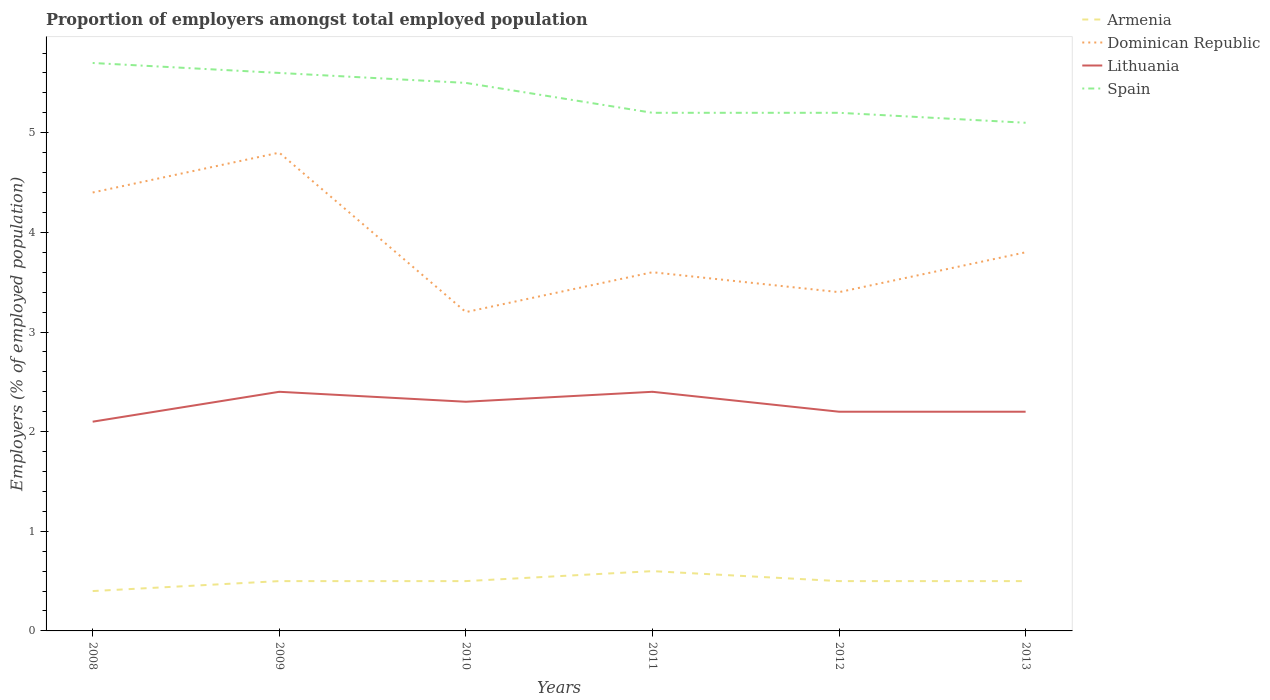How many different coloured lines are there?
Keep it short and to the point. 4. Is the number of lines equal to the number of legend labels?
Your answer should be very brief. Yes. Across all years, what is the maximum proportion of employers in Lithuania?
Your answer should be very brief. 2.1. In which year was the proportion of employers in Spain maximum?
Ensure brevity in your answer.  2013. What is the total proportion of employers in Dominican Republic in the graph?
Your response must be concise. 0.6. What is the difference between the highest and the second highest proportion of employers in Dominican Republic?
Your response must be concise. 1.6. Is the proportion of employers in Armenia strictly greater than the proportion of employers in Dominican Republic over the years?
Ensure brevity in your answer.  Yes. Are the values on the major ticks of Y-axis written in scientific E-notation?
Your answer should be very brief. No. Does the graph contain any zero values?
Offer a very short reply. No. Does the graph contain grids?
Provide a short and direct response. No. Where does the legend appear in the graph?
Provide a succinct answer. Top right. What is the title of the graph?
Give a very brief answer. Proportion of employers amongst total employed population. Does "Nicaragua" appear as one of the legend labels in the graph?
Offer a very short reply. No. What is the label or title of the Y-axis?
Offer a very short reply. Employers (% of employed population). What is the Employers (% of employed population) in Armenia in 2008?
Ensure brevity in your answer.  0.4. What is the Employers (% of employed population) in Dominican Republic in 2008?
Provide a short and direct response. 4.4. What is the Employers (% of employed population) in Lithuania in 2008?
Keep it short and to the point. 2.1. What is the Employers (% of employed population) in Spain in 2008?
Give a very brief answer. 5.7. What is the Employers (% of employed population) in Armenia in 2009?
Offer a terse response. 0.5. What is the Employers (% of employed population) of Dominican Republic in 2009?
Provide a short and direct response. 4.8. What is the Employers (% of employed population) in Lithuania in 2009?
Ensure brevity in your answer.  2.4. What is the Employers (% of employed population) in Spain in 2009?
Make the answer very short. 5.6. What is the Employers (% of employed population) in Armenia in 2010?
Keep it short and to the point. 0.5. What is the Employers (% of employed population) of Dominican Republic in 2010?
Keep it short and to the point. 3.2. What is the Employers (% of employed population) in Lithuania in 2010?
Provide a succinct answer. 2.3. What is the Employers (% of employed population) of Spain in 2010?
Your answer should be very brief. 5.5. What is the Employers (% of employed population) of Armenia in 2011?
Your answer should be very brief. 0.6. What is the Employers (% of employed population) in Dominican Republic in 2011?
Provide a short and direct response. 3.6. What is the Employers (% of employed population) of Lithuania in 2011?
Ensure brevity in your answer.  2.4. What is the Employers (% of employed population) of Spain in 2011?
Keep it short and to the point. 5.2. What is the Employers (% of employed population) of Armenia in 2012?
Your answer should be compact. 0.5. What is the Employers (% of employed population) of Dominican Republic in 2012?
Offer a terse response. 3.4. What is the Employers (% of employed population) in Lithuania in 2012?
Your response must be concise. 2.2. What is the Employers (% of employed population) of Spain in 2012?
Make the answer very short. 5.2. What is the Employers (% of employed population) in Dominican Republic in 2013?
Your response must be concise. 3.8. What is the Employers (% of employed population) of Lithuania in 2013?
Your answer should be compact. 2.2. What is the Employers (% of employed population) of Spain in 2013?
Your answer should be compact. 5.1. Across all years, what is the maximum Employers (% of employed population) of Armenia?
Your answer should be compact. 0.6. Across all years, what is the maximum Employers (% of employed population) in Dominican Republic?
Keep it short and to the point. 4.8. Across all years, what is the maximum Employers (% of employed population) of Lithuania?
Give a very brief answer. 2.4. Across all years, what is the maximum Employers (% of employed population) in Spain?
Give a very brief answer. 5.7. Across all years, what is the minimum Employers (% of employed population) of Armenia?
Offer a very short reply. 0.4. Across all years, what is the minimum Employers (% of employed population) in Dominican Republic?
Your response must be concise. 3.2. Across all years, what is the minimum Employers (% of employed population) in Lithuania?
Provide a succinct answer. 2.1. Across all years, what is the minimum Employers (% of employed population) of Spain?
Offer a terse response. 5.1. What is the total Employers (% of employed population) of Dominican Republic in the graph?
Your response must be concise. 23.2. What is the total Employers (% of employed population) of Lithuania in the graph?
Your answer should be compact. 13.6. What is the total Employers (% of employed population) in Spain in the graph?
Provide a short and direct response. 32.3. What is the difference between the Employers (% of employed population) of Armenia in 2008 and that in 2009?
Your answer should be very brief. -0.1. What is the difference between the Employers (% of employed population) in Dominican Republic in 2008 and that in 2009?
Keep it short and to the point. -0.4. What is the difference between the Employers (% of employed population) in Lithuania in 2008 and that in 2009?
Your response must be concise. -0.3. What is the difference between the Employers (% of employed population) in Spain in 2008 and that in 2009?
Your response must be concise. 0.1. What is the difference between the Employers (% of employed population) in Armenia in 2008 and that in 2010?
Give a very brief answer. -0.1. What is the difference between the Employers (% of employed population) of Armenia in 2008 and that in 2011?
Your answer should be compact. -0.2. What is the difference between the Employers (% of employed population) in Dominican Republic in 2008 and that in 2011?
Give a very brief answer. 0.8. What is the difference between the Employers (% of employed population) of Spain in 2008 and that in 2011?
Keep it short and to the point. 0.5. What is the difference between the Employers (% of employed population) in Dominican Republic in 2008 and that in 2012?
Your response must be concise. 1. What is the difference between the Employers (% of employed population) of Spain in 2008 and that in 2012?
Offer a terse response. 0.5. What is the difference between the Employers (% of employed population) of Lithuania in 2008 and that in 2013?
Make the answer very short. -0.1. What is the difference between the Employers (% of employed population) of Spain in 2008 and that in 2013?
Give a very brief answer. 0.6. What is the difference between the Employers (% of employed population) in Armenia in 2009 and that in 2010?
Your response must be concise. 0. What is the difference between the Employers (% of employed population) in Lithuania in 2009 and that in 2010?
Ensure brevity in your answer.  0.1. What is the difference between the Employers (% of employed population) in Spain in 2009 and that in 2010?
Give a very brief answer. 0.1. What is the difference between the Employers (% of employed population) in Lithuania in 2009 and that in 2011?
Give a very brief answer. 0. What is the difference between the Employers (% of employed population) of Armenia in 2009 and that in 2012?
Your answer should be very brief. 0. What is the difference between the Employers (% of employed population) of Dominican Republic in 2009 and that in 2012?
Provide a short and direct response. 1.4. What is the difference between the Employers (% of employed population) in Spain in 2009 and that in 2012?
Provide a succinct answer. 0.4. What is the difference between the Employers (% of employed population) in Lithuania in 2009 and that in 2013?
Provide a short and direct response. 0.2. What is the difference between the Employers (% of employed population) in Armenia in 2010 and that in 2011?
Provide a short and direct response. -0.1. What is the difference between the Employers (% of employed population) in Spain in 2010 and that in 2011?
Provide a succinct answer. 0.3. What is the difference between the Employers (% of employed population) in Dominican Republic in 2010 and that in 2012?
Offer a terse response. -0.2. What is the difference between the Employers (% of employed population) of Lithuania in 2010 and that in 2012?
Offer a very short reply. 0.1. What is the difference between the Employers (% of employed population) in Spain in 2010 and that in 2012?
Your response must be concise. 0.3. What is the difference between the Employers (% of employed population) in Armenia in 2010 and that in 2013?
Keep it short and to the point. 0. What is the difference between the Employers (% of employed population) of Dominican Republic in 2010 and that in 2013?
Provide a succinct answer. -0.6. What is the difference between the Employers (% of employed population) in Lithuania in 2010 and that in 2013?
Offer a terse response. 0.1. What is the difference between the Employers (% of employed population) in Spain in 2010 and that in 2013?
Your response must be concise. 0.4. What is the difference between the Employers (% of employed population) of Armenia in 2011 and that in 2012?
Keep it short and to the point. 0.1. What is the difference between the Employers (% of employed population) of Dominican Republic in 2011 and that in 2012?
Your answer should be very brief. 0.2. What is the difference between the Employers (% of employed population) of Lithuania in 2011 and that in 2012?
Ensure brevity in your answer.  0.2. What is the difference between the Employers (% of employed population) in Spain in 2011 and that in 2012?
Ensure brevity in your answer.  0. What is the difference between the Employers (% of employed population) in Spain in 2011 and that in 2013?
Offer a very short reply. 0.1. What is the difference between the Employers (% of employed population) of Armenia in 2012 and that in 2013?
Ensure brevity in your answer.  0. What is the difference between the Employers (% of employed population) of Dominican Republic in 2012 and that in 2013?
Your answer should be very brief. -0.4. What is the difference between the Employers (% of employed population) in Armenia in 2008 and the Employers (% of employed population) in Dominican Republic in 2009?
Give a very brief answer. -4.4. What is the difference between the Employers (% of employed population) of Armenia in 2008 and the Employers (% of employed population) of Lithuania in 2009?
Keep it short and to the point. -2. What is the difference between the Employers (% of employed population) of Dominican Republic in 2008 and the Employers (% of employed population) of Lithuania in 2009?
Ensure brevity in your answer.  2. What is the difference between the Employers (% of employed population) of Dominican Republic in 2008 and the Employers (% of employed population) of Spain in 2009?
Keep it short and to the point. -1.2. What is the difference between the Employers (% of employed population) of Armenia in 2008 and the Employers (% of employed population) of Dominican Republic in 2010?
Provide a succinct answer. -2.8. What is the difference between the Employers (% of employed population) in Armenia in 2008 and the Employers (% of employed population) in Lithuania in 2010?
Your answer should be compact. -1.9. What is the difference between the Employers (% of employed population) of Armenia in 2008 and the Employers (% of employed population) of Spain in 2010?
Give a very brief answer. -5.1. What is the difference between the Employers (% of employed population) in Dominican Republic in 2008 and the Employers (% of employed population) in Lithuania in 2010?
Give a very brief answer. 2.1. What is the difference between the Employers (% of employed population) of Armenia in 2008 and the Employers (% of employed population) of Spain in 2011?
Give a very brief answer. -4.8. What is the difference between the Employers (% of employed population) in Dominican Republic in 2008 and the Employers (% of employed population) in Spain in 2011?
Offer a terse response. -0.8. What is the difference between the Employers (% of employed population) of Lithuania in 2008 and the Employers (% of employed population) of Spain in 2011?
Make the answer very short. -3.1. What is the difference between the Employers (% of employed population) of Armenia in 2008 and the Employers (% of employed population) of Lithuania in 2012?
Your answer should be very brief. -1.8. What is the difference between the Employers (% of employed population) in Dominican Republic in 2008 and the Employers (% of employed population) in Lithuania in 2012?
Provide a succinct answer. 2.2. What is the difference between the Employers (% of employed population) of Armenia in 2008 and the Employers (% of employed population) of Lithuania in 2013?
Ensure brevity in your answer.  -1.8. What is the difference between the Employers (% of employed population) in Armenia in 2008 and the Employers (% of employed population) in Spain in 2013?
Offer a terse response. -4.7. What is the difference between the Employers (% of employed population) of Dominican Republic in 2008 and the Employers (% of employed population) of Spain in 2013?
Provide a succinct answer. -0.7. What is the difference between the Employers (% of employed population) in Lithuania in 2008 and the Employers (% of employed population) in Spain in 2013?
Offer a very short reply. -3. What is the difference between the Employers (% of employed population) of Armenia in 2009 and the Employers (% of employed population) of Dominican Republic in 2010?
Offer a terse response. -2.7. What is the difference between the Employers (% of employed population) of Armenia in 2009 and the Employers (% of employed population) of Lithuania in 2010?
Ensure brevity in your answer.  -1.8. What is the difference between the Employers (% of employed population) in Dominican Republic in 2009 and the Employers (% of employed population) in Spain in 2010?
Your answer should be compact. -0.7. What is the difference between the Employers (% of employed population) of Armenia in 2009 and the Employers (% of employed population) of Spain in 2012?
Provide a short and direct response. -4.7. What is the difference between the Employers (% of employed population) of Lithuania in 2009 and the Employers (% of employed population) of Spain in 2012?
Your answer should be compact. -2.8. What is the difference between the Employers (% of employed population) in Dominican Republic in 2009 and the Employers (% of employed population) in Spain in 2013?
Ensure brevity in your answer.  -0.3. What is the difference between the Employers (% of employed population) of Lithuania in 2009 and the Employers (% of employed population) of Spain in 2013?
Your answer should be very brief. -2.7. What is the difference between the Employers (% of employed population) of Armenia in 2010 and the Employers (% of employed population) of Dominican Republic in 2011?
Your response must be concise. -3.1. What is the difference between the Employers (% of employed population) of Armenia in 2010 and the Employers (% of employed population) of Lithuania in 2011?
Your response must be concise. -1.9. What is the difference between the Employers (% of employed population) in Armenia in 2010 and the Employers (% of employed population) in Spain in 2011?
Make the answer very short. -4.7. What is the difference between the Employers (% of employed population) of Dominican Republic in 2010 and the Employers (% of employed population) of Lithuania in 2011?
Your response must be concise. 0.8. What is the difference between the Employers (% of employed population) of Dominican Republic in 2010 and the Employers (% of employed population) of Spain in 2011?
Make the answer very short. -2. What is the difference between the Employers (% of employed population) in Lithuania in 2010 and the Employers (% of employed population) in Spain in 2011?
Offer a terse response. -2.9. What is the difference between the Employers (% of employed population) in Armenia in 2010 and the Employers (% of employed population) in Dominican Republic in 2012?
Make the answer very short. -2.9. What is the difference between the Employers (% of employed population) of Armenia in 2010 and the Employers (% of employed population) of Lithuania in 2012?
Your answer should be very brief. -1.7. What is the difference between the Employers (% of employed population) in Armenia in 2010 and the Employers (% of employed population) in Dominican Republic in 2013?
Your response must be concise. -3.3. What is the difference between the Employers (% of employed population) of Armenia in 2010 and the Employers (% of employed population) of Lithuania in 2013?
Provide a succinct answer. -1.7. What is the difference between the Employers (% of employed population) in Armenia in 2010 and the Employers (% of employed population) in Spain in 2013?
Offer a very short reply. -4.6. What is the difference between the Employers (% of employed population) of Dominican Republic in 2010 and the Employers (% of employed population) of Lithuania in 2013?
Your answer should be compact. 1. What is the difference between the Employers (% of employed population) in Dominican Republic in 2010 and the Employers (% of employed population) in Spain in 2013?
Your answer should be compact. -1.9. What is the difference between the Employers (% of employed population) in Lithuania in 2010 and the Employers (% of employed population) in Spain in 2013?
Ensure brevity in your answer.  -2.8. What is the difference between the Employers (% of employed population) in Armenia in 2011 and the Employers (% of employed population) in Lithuania in 2012?
Your response must be concise. -1.6. What is the difference between the Employers (% of employed population) of Armenia in 2011 and the Employers (% of employed population) of Spain in 2012?
Make the answer very short. -4.6. What is the difference between the Employers (% of employed population) of Dominican Republic in 2011 and the Employers (% of employed population) of Spain in 2012?
Offer a terse response. -1.6. What is the difference between the Employers (% of employed population) of Lithuania in 2011 and the Employers (% of employed population) of Spain in 2012?
Make the answer very short. -2.8. What is the difference between the Employers (% of employed population) of Armenia in 2011 and the Employers (% of employed population) of Dominican Republic in 2013?
Your answer should be compact. -3.2. What is the difference between the Employers (% of employed population) in Armenia in 2011 and the Employers (% of employed population) in Lithuania in 2013?
Keep it short and to the point. -1.6. What is the difference between the Employers (% of employed population) of Armenia in 2011 and the Employers (% of employed population) of Spain in 2013?
Give a very brief answer. -4.5. What is the difference between the Employers (% of employed population) of Dominican Republic in 2011 and the Employers (% of employed population) of Spain in 2013?
Keep it short and to the point. -1.5. What is the difference between the Employers (% of employed population) in Armenia in 2012 and the Employers (% of employed population) in Dominican Republic in 2013?
Your answer should be very brief. -3.3. What is the difference between the Employers (% of employed population) in Armenia in 2012 and the Employers (% of employed population) in Lithuania in 2013?
Provide a succinct answer. -1.7. What is the difference between the Employers (% of employed population) in Dominican Republic in 2012 and the Employers (% of employed population) in Lithuania in 2013?
Keep it short and to the point. 1.2. What is the difference between the Employers (% of employed population) of Lithuania in 2012 and the Employers (% of employed population) of Spain in 2013?
Provide a succinct answer. -2.9. What is the average Employers (% of employed population) of Dominican Republic per year?
Give a very brief answer. 3.87. What is the average Employers (% of employed population) in Lithuania per year?
Offer a terse response. 2.27. What is the average Employers (% of employed population) of Spain per year?
Provide a short and direct response. 5.38. In the year 2008, what is the difference between the Employers (% of employed population) of Armenia and Employers (% of employed population) of Dominican Republic?
Offer a terse response. -4. In the year 2009, what is the difference between the Employers (% of employed population) in Armenia and Employers (% of employed population) in Dominican Republic?
Give a very brief answer. -4.3. In the year 2009, what is the difference between the Employers (% of employed population) in Armenia and Employers (% of employed population) in Lithuania?
Your response must be concise. -1.9. In the year 2009, what is the difference between the Employers (% of employed population) in Dominican Republic and Employers (% of employed population) in Spain?
Your answer should be very brief. -0.8. In the year 2009, what is the difference between the Employers (% of employed population) in Lithuania and Employers (% of employed population) in Spain?
Make the answer very short. -3.2. In the year 2010, what is the difference between the Employers (% of employed population) of Armenia and Employers (% of employed population) of Dominican Republic?
Give a very brief answer. -2.7. In the year 2010, what is the difference between the Employers (% of employed population) in Armenia and Employers (% of employed population) in Lithuania?
Ensure brevity in your answer.  -1.8. In the year 2010, what is the difference between the Employers (% of employed population) in Armenia and Employers (% of employed population) in Spain?
Provide a succinct answer. -5. In the year 2010, what is the difference between the Employers (% of employed population) in Dominican Republic and Employers (% of employed population) in Spain?
Offer a terse response. -2.3. In the year 2011, what is the difference between the Employers (% of employed population) of Armenia and Employers (% of employed population) of Dominican Republic?
Your answer should be very brief. -3. In the year 2011, what is the difference between the Employers (% of employed population) in Armenia and Employers (% of employed population) in Lithuania?
Offer a terse response. -1.8. In the year 2011, what is the difference between the Employers (% of employed population) of Lithuania and Employers (% of employed population) of Spain?
Provide a short and direct response. -2.8. In the year 2012, what is the difference between the Employers (% of employed population) in Armenia and Employers (% of employed population) in Lithuania?
Provide a short and direct response. -1.7. In the year 2012, what is the difference between the Employers (% of employed population) in Armenia and Employers (% of employed population) in Spain?
Your answer should be very brief. -4.7. In the year 2012, what is the difference between the Employers (% of employed population) of Dominican Republic and Employers (% of employed population) of Lithuania?
Your answer should be compact. 1.2. In the year 2012, what is the difference between the Employers (% of employed population) of Lithuania and Employers (% of employed population) of Spain?
Give a very brief answer. -3. In the year 2013, what is the difference between the Employers (% of employed population) in Armenia and Employers (% of employed population) in Lithuania?
Offer a terse response. -1.7. In the year 2013, what is the difference between the Employers (% of employed population) of Dominican Republic and Employers (% of employed population) of Spain?
Your answer should be compact. -1.3. What is the ratio of the Employers (% of employed population) in Armenia in 2008 to that in 2009?
Ensure brevity in your answer.  0.8. What is the ratio of the Employers (% of employed population) in Lithuania in 2008 to that in 2009?
Your response must be concise. 0.88. What is the ratio of the Employers (% of employed population) in Spain in 2008 to that in 2009?
Your answer should be very brief. 1.02. What is the ratio of the Employers (% of employed population) of Armenia in 2008 to that in 2010?
Provide a short and direct response. 0.8. What is the ratio of the Employers (% of employed population) in Dominican Republic in 2008 to that in 2010?
Your response must be concise. 1.38. What is the ratio of the Employers (% of employed population) of Spain in 2008 to that in 2010?
Your answer should be very brief. 1.04. What is the ratio of the Employers (% of employed population) in Dominican Republic in 2008 to that in 2011?
Provide a succinct answer. 1.22. What is the ratio of the Employers (% of employed population) of Lithuania in 2008 to that in 2011?
Offer a terse response. 0.88. What is the ratio of the Employers (% of employed population) of Spain in 2008 to that in 2011?
Give a very brief answer. 1.1. What is the ratio of the Employers (% of employed population) in Dominican Republic in 2008 to that in 2012?
Your answer should be compact. 1.29. What is the ratio of the Employers (% of employed population) of Lithuania in 2008 to that in 2012?
Provide a succinct answer. 0.95. What is the ratio of the Employers (% of employed population) in Spain in 2008 to that in 2012?
Provide a succinct answer. 1.1. What is the ratio of the Employers (% of employed population) in Armenia in 2008 to that in 2013?
Make the answer very short. 0.8. What is the ratio of the Employers (% of employed population) in Dominican Republic in 2008 to that in 2013?
Offer a terse response. 1.16. What is the ratio of the Employers (% of employed population) in Lithuania in 2008 to that in 2013?
Ensure brevity in your answer.  0.95. What is the ratio of the Employers (% of employed population) of Spain in 2008 to that in 2013?
Your response must be concise. 1.12. What is the ratio of the Employers (% of employed population) in Lithuania in 2009 to that in 2010?
Give a very brief answer. 1.04. What is the ratio of the Employers (% of employed population) in Spain in 2009 to that in 2010?
Provide a short and direct response. 1.02. What is the ratio of the Employers (% of employed population) of Armenia in 2009 to that in 2011?
Give a very brief answer. 0.83. What is the ratio of the Employers (% of employed population) of Dominican Republic in 2009 to that in 2011?
Provide a succinct answer. 1.33. What is the ratio of the Employers (% of employed population) in Lithuania in 2009 to that in 2011?
Offer a very short reply. 1. What is the ratio of the Employers (% of employed population) of Spain in 2009 to that in 2011?
Ensure brevity in your answer.  1.08. What is the ratio of the Employers (% of employed population) in Armenia in 2009 to that in 2012?
Keep it short and to the point. 1. What is the ratio of the Employers (% of employed population) in Dominican Republic in 2009 to that in 2012?
Your answer should be very brief. 1.41. What is the ratio of the Employers (% of employed population) in Lithuania in 2009 to that in 2012?
Provide a short and direct response. 1.09. What is the ratio of the Employers (% of employed population) in Spain in 2009 to that in 2012?
Ensure brevity in your answer.  1.08. What is the ratio of the Employers (% of employed population) in Dominican Republic in 2009 to that in 2013?
Ensure brevity in your answer.  1.26. What is the ratio of the Employers (% of employed population) in Lithuania in 2009 to that in 2013?
Ensure brevity in your answer.  1.09. What is the ratio of the Employers (% of employed population) of Spain in 2009 to that in 2013?
Your response must be concise. 1.1. What is the ratio of the Employers (% of employed population) of Armenia in 2010 to that in 2011?
Ensure brevity in your answer.  0.83. What is the ratio of the Employers (% of employed population) in Dominican Republic in 2010 to that in 2011?
Your response must be concise. 0.89. What is the ratio of the Employers (% of employed population) of Spain in 2010 to that in 2011?
Your answer should be compact. 1.06. What is the ratio of the Employers (% of employed population) in Dominican Republic in 2010 to that in 2012?
Your response must be concise. 0.94. What is the ratio of the Employers (% of employed population) of Lithuania in 2010 to that in 2012?
Ensure brevity in your answer.  1.05. What is the ratio of the Employers (% of employed population) of Spain in 2010 to that in 2012?
Offer a very short reply. 1.06. What is the ratio of the Employers (% of employed population) in Dominican Republic in 2010 to that in 2013?
Your answer should be compact. 0.84. What is the ratio of the Employers (% of employed population) of Lithuania in 2010 to that in 2013?
Ensure brevity in your answer.  1.05. What is the ratio of the Employers (% of employed population) in Spain in 2010 to that in 2013?
Offer a very short reply. 1.08. What is the ratio of the Employers (% of employed population) of Armenia in 2011 to that in 2012?
Your answer should be very brief. 1.2. What is the ratio of the Employers (% of employed population) of Dominican Republic in 2011 to that in 2012?
Your response must be concise. 1.06. What is the ratio of the Employers (% of employed population) in Spain in 2011 to that in 2012?
Your response must be concise. 1. What is the ratio of the Employers (% of employed population) in Lithuania in 2011 to that in 2013?
Provide a succinct answer. 1.09. What is the ratio of the Employers (% of employed population) of Spain in 2011 to that in 2013?
Ensure brevity in your answer.  1.02. What is the ratio of the Employers (% of employed population) in Armenia in 2012 to that in 2013?
Offer a very short reply. 1. What is the ratio of the Employers (% of employed population) in Dominican Republic in 2012 to that in 2013?
Offer a terse response. 0.89. What is the ratio of the Employers (% of employed population) in Spain in 2012 to that in 2013?
Provide a short and direct response. 1.02. What is the difference between the highest and the second highest Employers (% of employed population) of Dominican Republic?
Offer a very short reply. 0.4. What is the difference between the highest and the second highest Employers (% of employed population) of Lithuania?
Offer a terse response. 0. What is the difference between the highest and the lowest Employers (% of employed population) of Dominican Republic?
Give a very brief answer. 1.6. What is the difference between the highest and the lowest Employers (% of employed population) of Lithuania?
Your response must be concise. 0.3. 